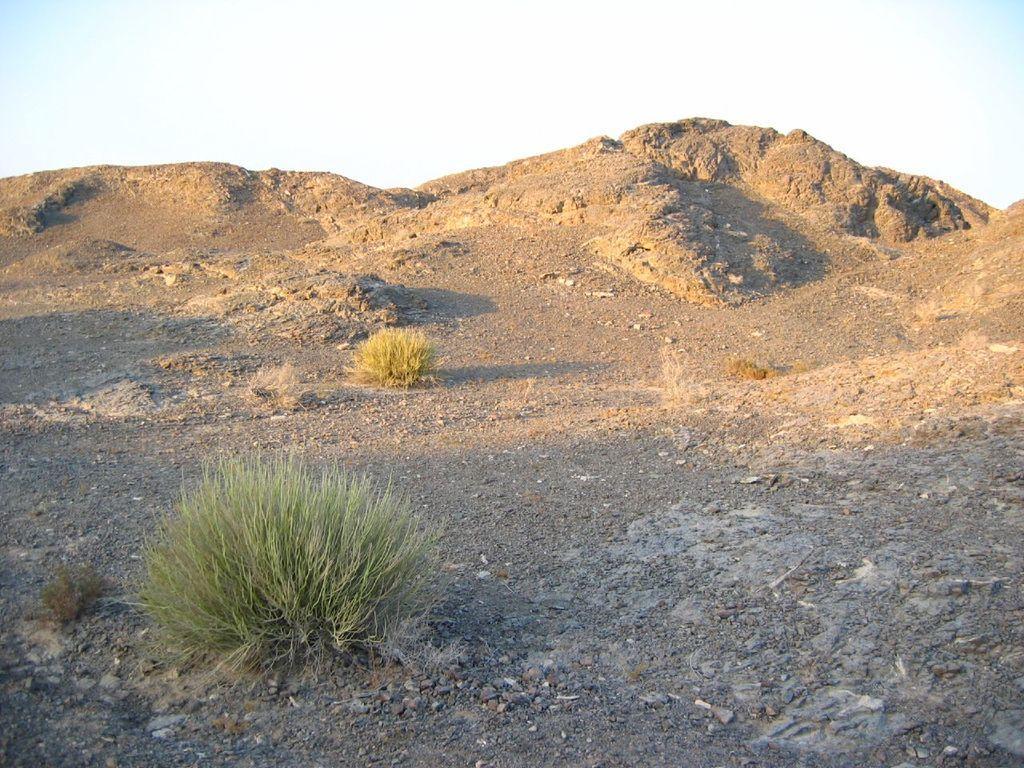In one or two sentences, can you explain what this image depicts? In the foreground of the image there is grass,stones. In the background of the image there are rock structures and sky. 